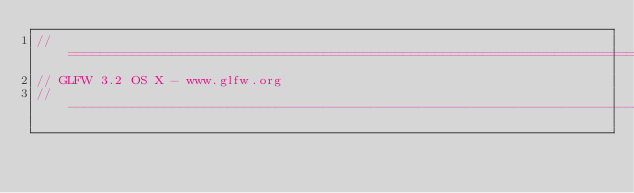Convert code to text. <code><loc_0><loc_0><loc_500><loc_500><_ObjectiveC_>//========================================================================
// GLFW 3.2 OS X - www.glfw.org
//------------------------------------------------------------------------</code> 